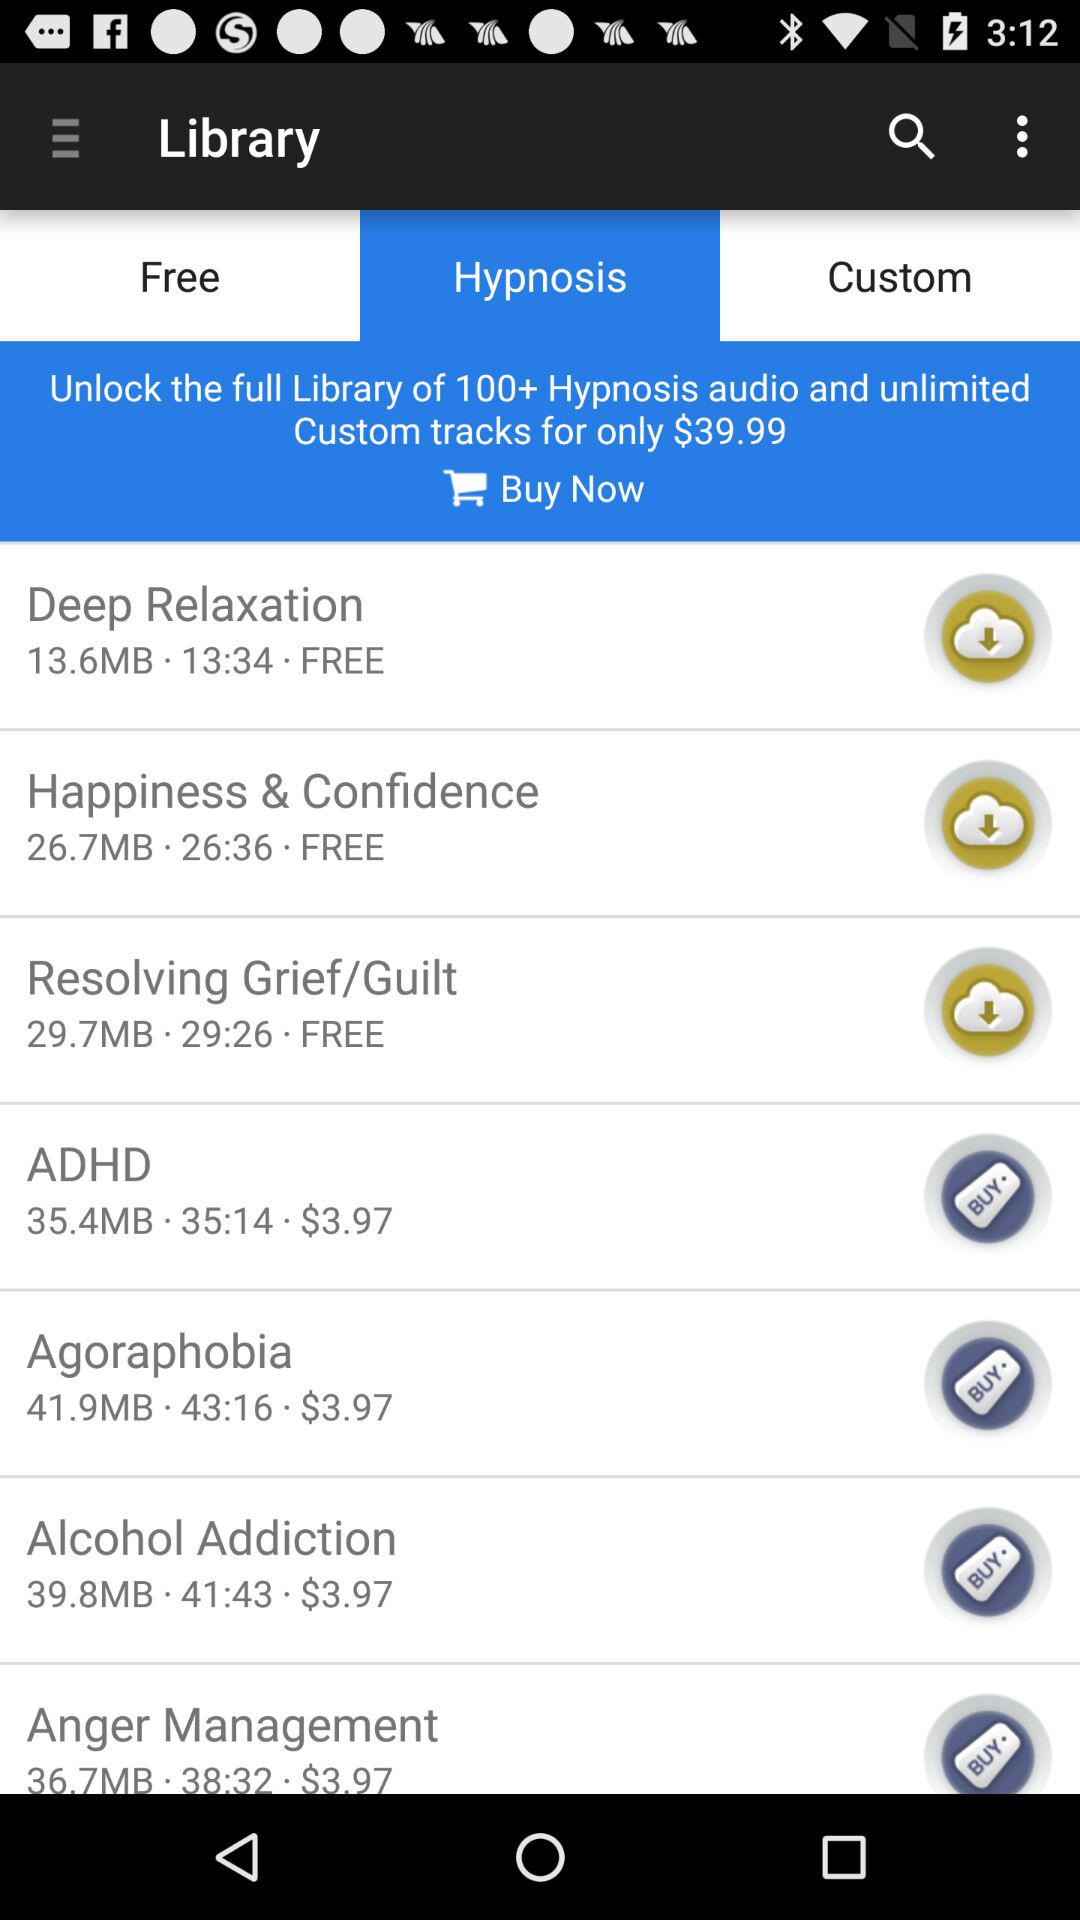Is happiness and confidence free or paid? Happiness and confidence are free. 